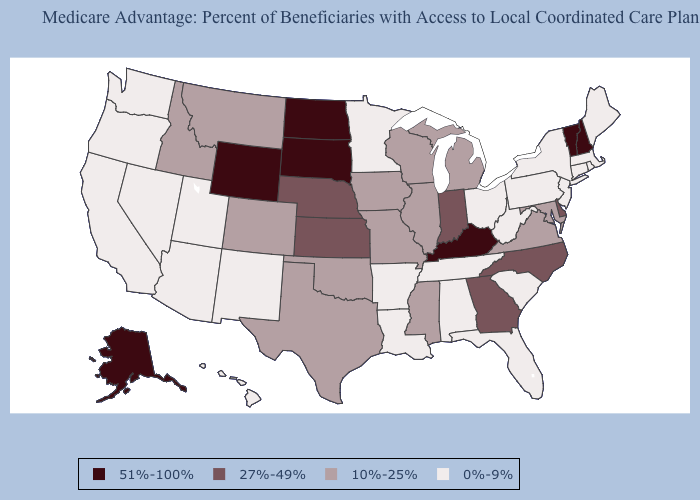Name the states that have a value in the range 27%-49%?
Write a very short answer. Delaware, Georgia, Indiana, Kansas, North Carolina, Nebraska. Among the states that border South Carolina , which have the lowest value?
Answer briefly. Georgia, North Carolina. Among the states that border Delaware , which have the highest value?
Give a very brief answer. Maryland. What is the lowest value in the South?
Concise answer only. 0%-9%. Name the states that have a value in the range 10%-25%?
Be succinct. Colorado, Iowa, Idaho, Illinois, Maryland, Michigan, Missouri, Mississippi, Montana, Oklahoma, Texas, Virginia, Wisconsin. Does Oregon have a higher value than California?
Keep it brief. No. What is the value of California?
Concise answer only. 0%-9%. Name the states that have a value in the range 51%-100%?
Write a very short answer. Alaska, Kentucky, North Dakota, New Hampshire, South Dakota, Vermont, Wyoming. Does Montana have the same value as Nevada?
Give a very brief answer. No. What is the lowest value in the USA?
Short answer required. 0%-9%. Which states have the lowest value in the USA?
Quick response, please. Alabama, Arkansas, Arizona, California, Connecticut, Florida, Hawaii, Louisiana, Massachusetts, Maine, Minnesota, New Jersey, New Mexico, Nevada, New York, Ohio, Oregon, Pennsylvania, Rhode Island, South Carolina, Tennessee, Utah, Washington, West Virginia. What is the highest value in the West ?
Give a very brief answer. 51%-100%. Name the states that have a value in the range 51%-100%?
Give a very brief answer. Alaska, Kentucky, North Dakota, New Hampshire, South Dakota, Vermont, Wyoming. Among the states that border Tennessee , which have the highest value?
Answer briefly. Kentucky. Does the map have missing data?
Answer briefly. No. 